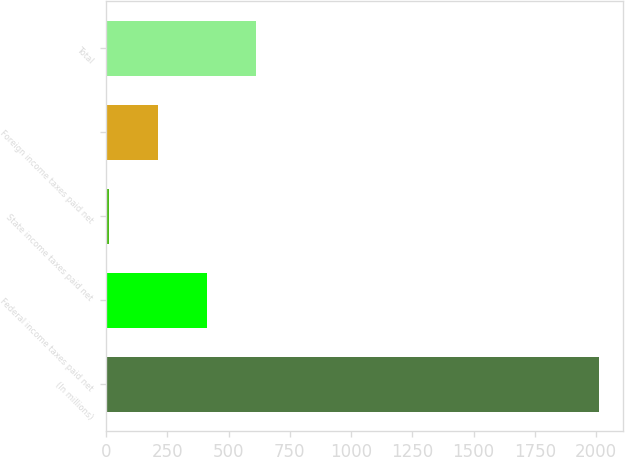Convert chart to OTSL. <chart><loc_0><loc_0><loc_500><loc_500><bar_chart><fcel>(In millions)<fcel>Federal income taxes paid net<fcel>State income taxes paid net<fcel>Foreign income taxes paid net<fcel>Total<nl><fcel>2011<fcel>411.72<fcel>11.9<fcel>211.81<fcel>611.63<nl></chart> 